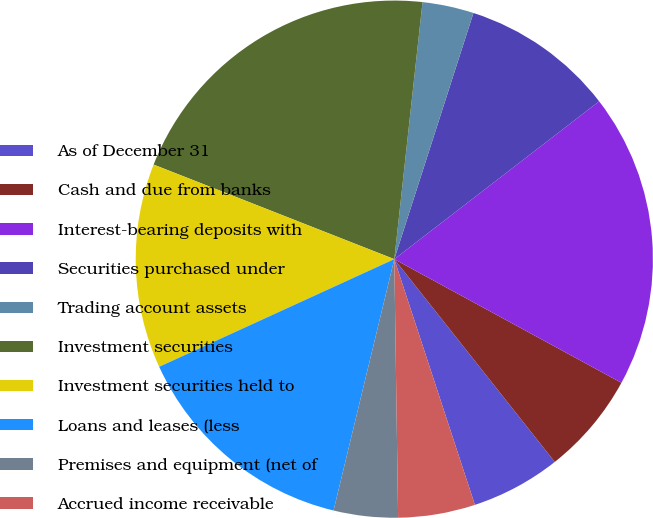Convert chart to OTSL. <chart><loc_0><loc_0><loc_500><loc_500><pie_chart><fcel>As of December 31<fcel>Cash and due from banks<fcel>Interest-bearing deposits with<fcel>Securities purchased under<fcel>Trading account assets<fcel>Investment securities<fcel>Investment securities held to<fcel>Loans and leases (less<fcel>Premises and equipment (net of<fcel>Accrued income receivable<nl><fcel>5.61%<fcel>6.41%<fcel>18.38%<fcel>9.6%<fcel>3.21%<fcel>20.78%<fcel>12.79%<fcel>14.39%<fcel>4.01%<fcel>4.81%<nl></chart> 